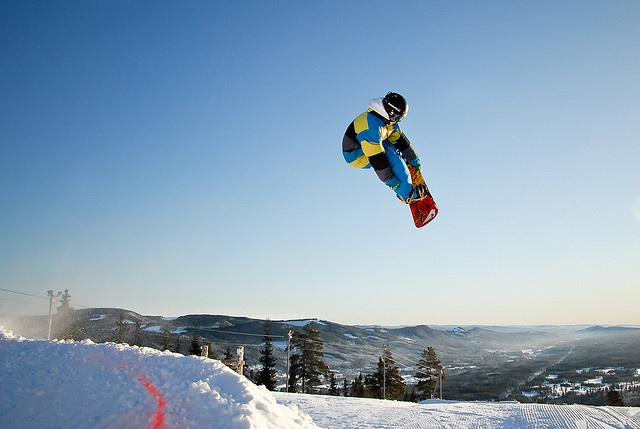Describe the objects in this image and their specific colors. I can see people in blue, black, and lightblue tones and snowboard in blue, maroon, black, and olive tones in this image. 